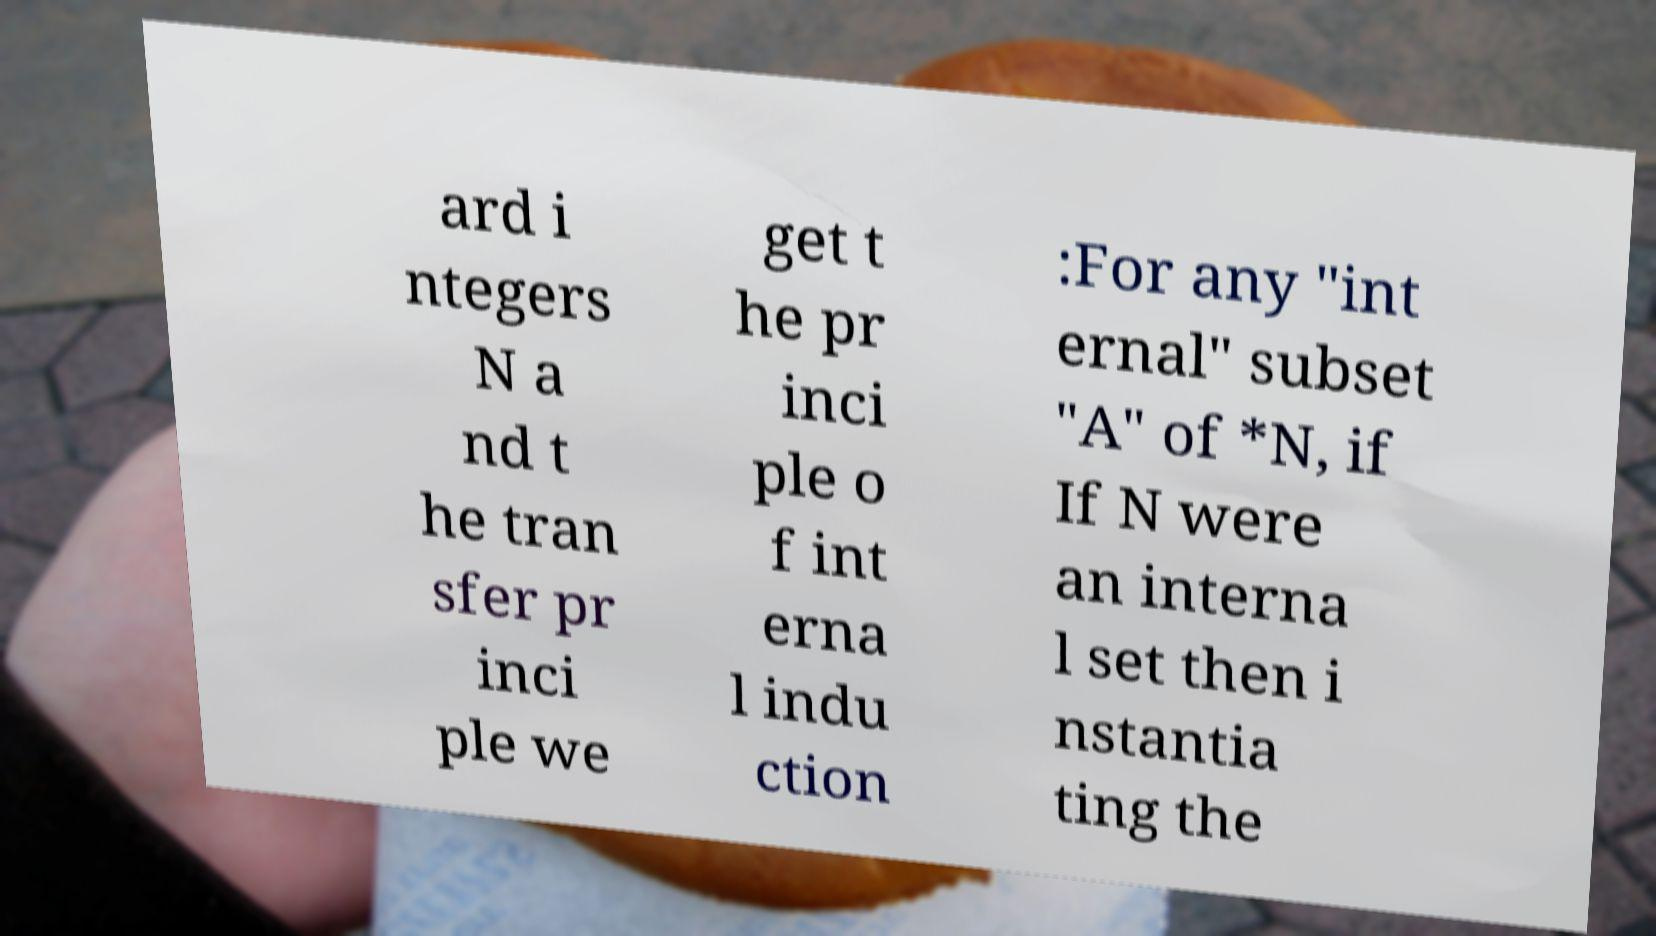There's text embedded in this image that I need extracted. Can you transcribe it verbatim? ard i ntegers N a nd t he tran sfer pr inci ple we get t he pr inci ple o f int erna l indu ction :For any "int ernal" subset "A" of *N, if If N were an interna l set then i nstantia ting the 